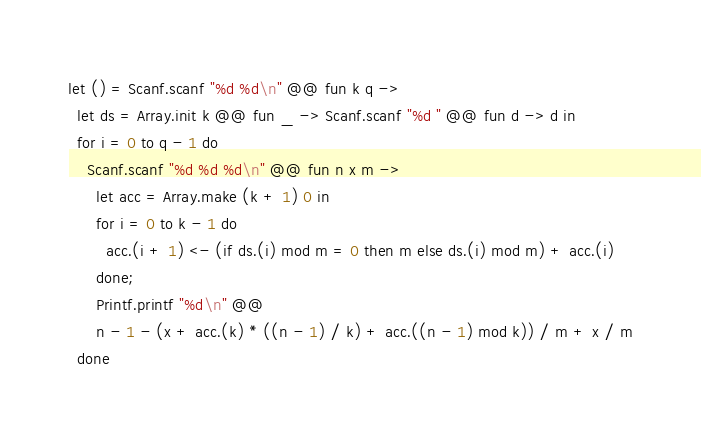Convert code to text. <code><loc_0><loc_0><loc_500><loc_500><_OCaml_>let () = Scanf.scanf "%d %d\n" @@ fun k q ->
  let ds = Array.init k @@ fun _ -> Scanf.scanf "%d " @@ fun d -> d in
  for i = 0 to q - 1 do
    Scanf.scanf "%d %d %d\n" @@ fun n x m ->
      let acc = Array.make (k + 1) 0 in
      for i = 0 to k - 1 do
        acc.(i + 1) <- (if ds.(i) mod m = 0 then m else ds.(i) mod m) + acc.(i)
      done;
      Printf.printf "%d\n" @@
      n - 1 - (x + acc.(k) * ((n - 1) / k) + acc.((n - 1) mod k)) / m + x / m
  done</code> 